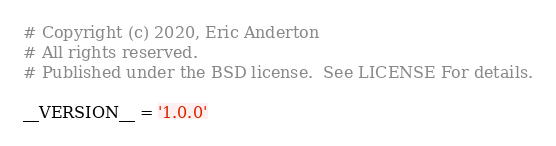Convert code to text. <code><loc_0><loc_0><loc_500><loc_500><_Python_># Copyright (c) 2020, Eric Anderton
# All rights reserved.
# Published under the BSD license.  See LICENSE For details.

__VERSION__ = '1.0.0'
</code> 